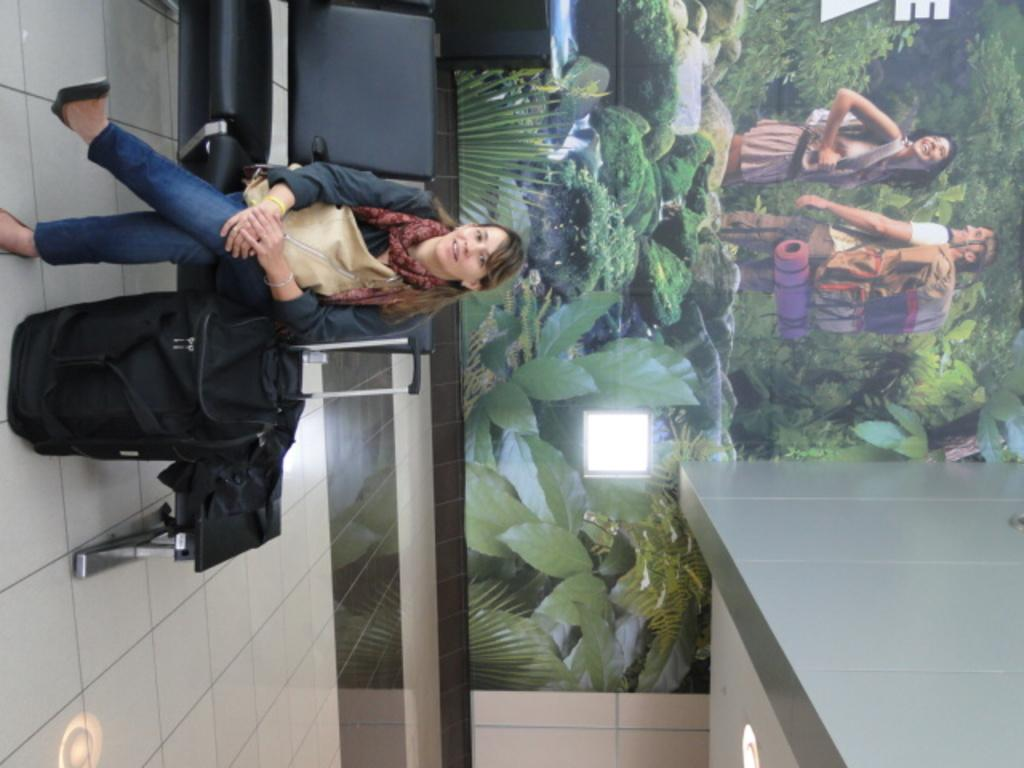What is the woman in the image doing? The woman is sitting on a chair in the image. What is located on the floor beside the chair? There is a bag on the floor beside the chair. What can be seen on the wall in the background? There is a banner on the wall in the background. What is visible in the background that might provide light? There are lights visible in the background. What other unspecified items can be seen in the background? There are other unspecified items in the background. What type of skin can be seen on the butter in the image? There is no butter present in the image, and therefore no skin can be observed on it. 